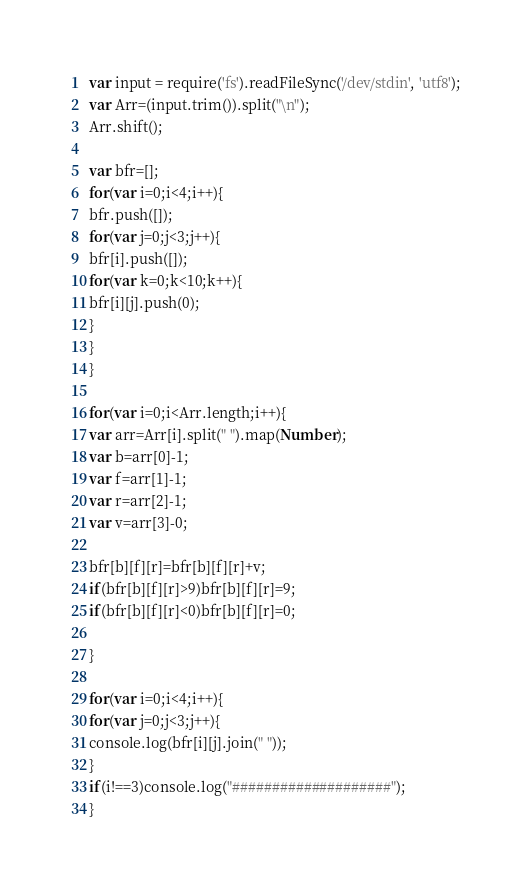<code> <loc_0><loc_0><loc_500><loc_500><_JavaScript_>var input = require('fs').readFileSync('/dev/stdin', 'utf8');
var Arr=(input.trim()).split("\n");
Arr.shift();
 
var bfr=[];
for(var i=0;i<4;i++){
bfr.push([]);
for(var j=0;j<3;j++){
bfr[i].push([]);
for(var k=0;k<10;k++){
bfr[i][j].push(0);
}
}
}
 
for(var i=0;i<Arr.length;i++){
var arr=Arr[i].split(" ").map(Number);
var b=arr[0]-1;
var f=arr[1]-1;
var r=arr[2]-1;
var v=arr[3]-0;
 
bfr[b][f][r]=bfr[b][f][r]+v;
if(bfr[b][f][r]>9)bfr[b][f][r]=9;
if(bfr[b][f][r]<0)bfr[b][f][r]=0;
 
}
 
for(var i=0;i<4;i++){
for(var j=0;j<3;j++){
console.log(bfr[i][j].join(" "));
}
if(i!==3)console.log("####################");
}</code> 